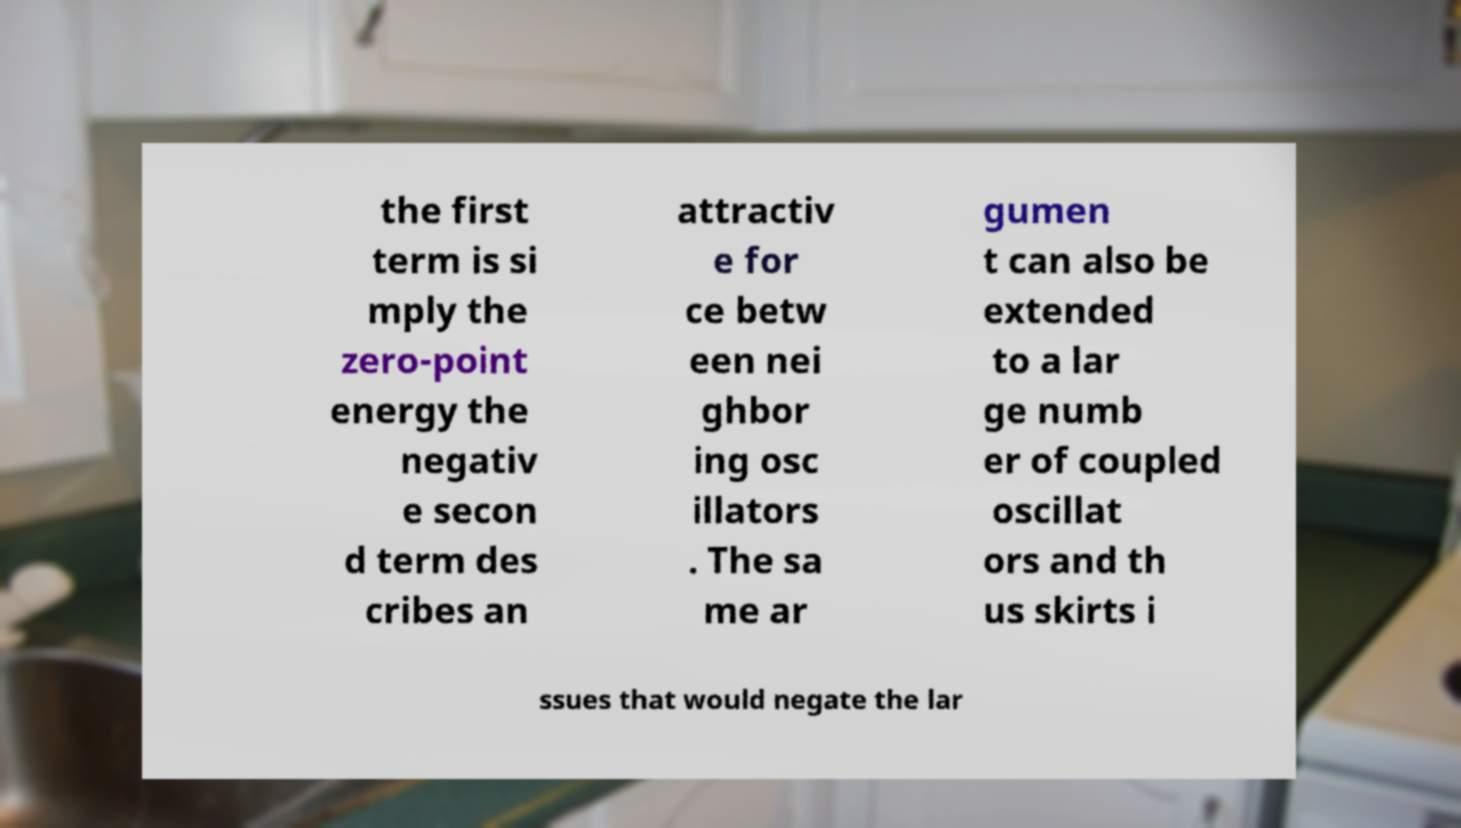Please read and relay the text visible in this image. What does it say? the first term is si mply the zero-point energy the negativ e secon d term des cribes an attractiv e for ce betw een nei ghbor ing osc illators . The sa me ar gumen t can also be extended to a lar ge numb er of coupled oscillat ors and th us skirts i ssues that would negate the lar 